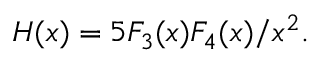Convert formula to latex. <formula><loc_0><loc_0><loc_500><loc_500>H ( x ) = 5 F _ { 3 } ( x ) F _ { 4 } ( x ) / x ^ { 2 } .</formula> 